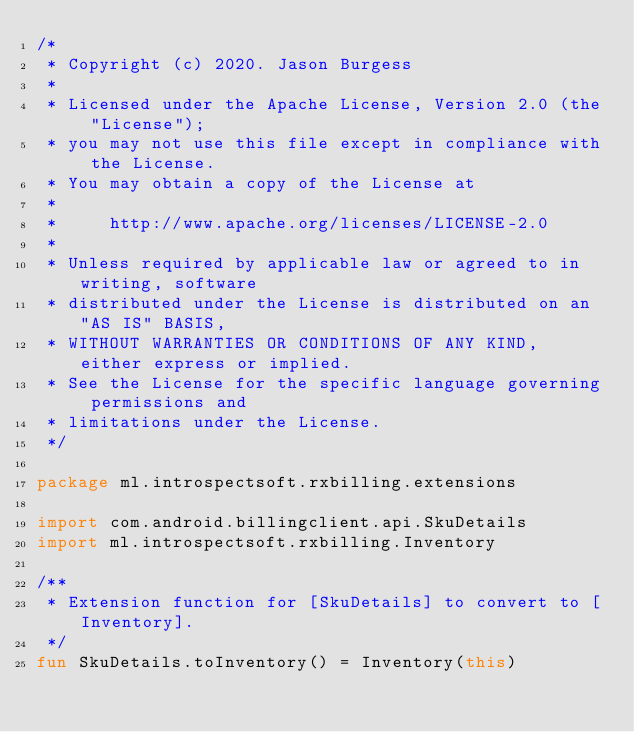Convert code to text. <code><loc_0><loc_0><loc_500><loc_500><_Kotlin_>/*
 * Copyright (c) 2020. Jason Burgess
 *
 * Licensed under the Apache License, Version 2.0 (the "License");
 * you may not use this file except in compliance with the License.
 * You may obtain a copy of the License at
 *
 *     http://www.apache.org/licenses/LICENSE-2.0
 *
 * Unless required by applicable law or agreed to in writing, software
 * distributed under the License is distributed on an "AS IS" BASIS,
 * WITHOUT WARRANTIES OR CONDITIONS OF ANY KIND, either express or implied.
 * See the License for the specific language governing permissions and
 * limitations under the License.
 */

package ml.introspectsoft.rxbilling.extensions

import com.android.billingclient.api.SkuDetails
import ml.introspectsoft.rxbilling.Inventory

/**
 * Extension function for [SkuDetails] to convert to [Inventory].
 */
fun SkuDetails.toInventory() = Inventory(this)</code> 